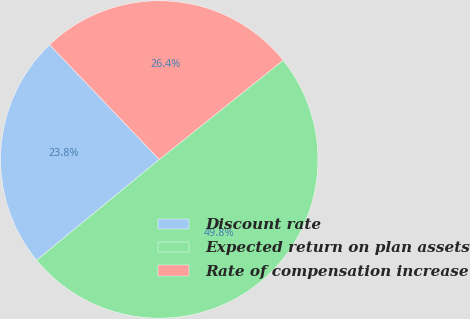<chart> <loc_0><loc_0><loc_500><loc_500><pie_chart><fcel>Discount rate<fcel>Expected return on plan assets<fcel>Rate of compensation increase<nl><fcel>23.81%<fcel>49.8%<fcel>26.39%<nl></chart> 